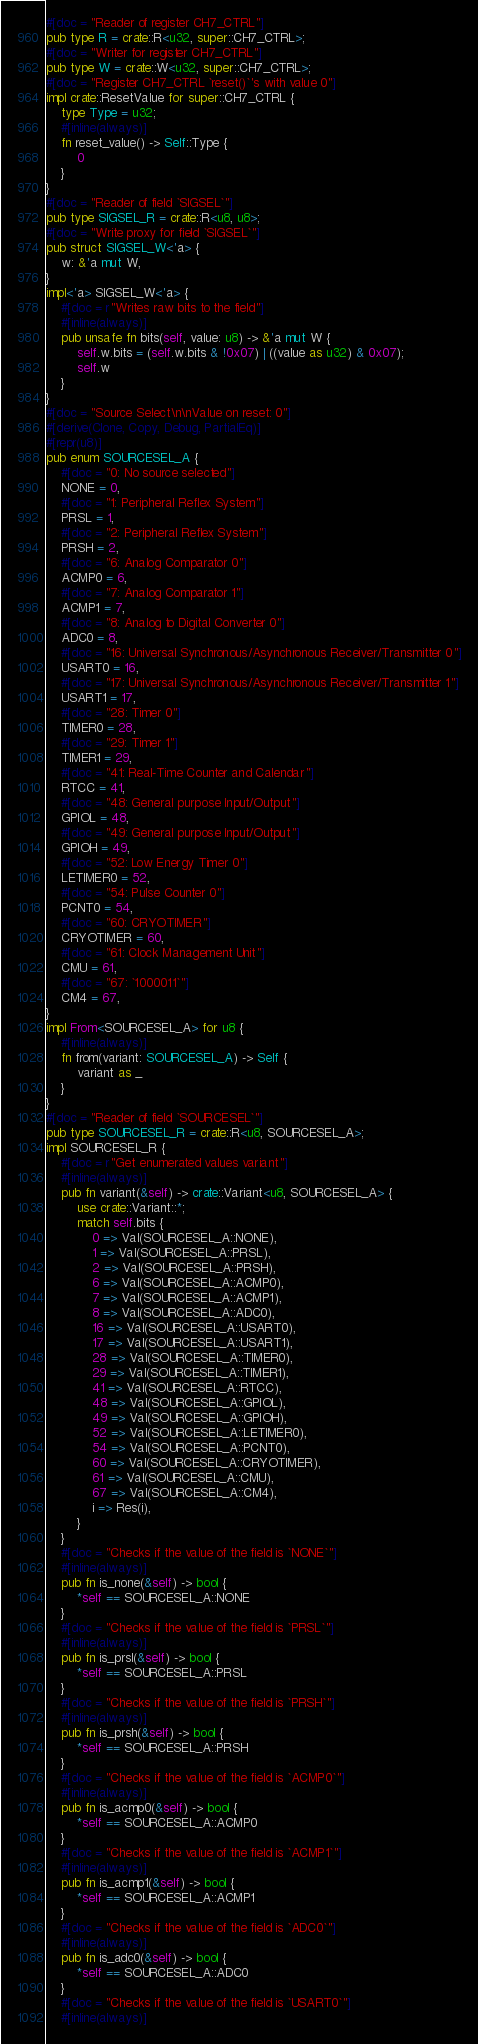Convert code to text. <code><loc_0><loc_0><loc_500><loc_500><_Rust_>#[doc = "Reader of register CH7_CTRL"]
pub type R = crate::R<u32, super::CH7_CTRL>;
#[doc = "Writer for register CH7_CTRL"]
pub type W = crate::W<u32, super::CH7_CTRL>;
#[doc = "Register CH7_CTRL `reset()`'s with value 0"]
impl crate::ResetValue for super::CH7_CTRL {
    type Type = u32;
    #[inline(always)]
    fn reset_value() -> Self::Type {
        0
    }
}
#[doc = "Reader of field `SIGSEL`"]
pub type SIGSEL_R = crate::R<u8, u8>;
#[doc = "Write proxy for field `SIGSEL`"]
pub struct SIGSEL_W<'a> {
    w: &'a mut W,
}
impl<'a> SIGSEL_W<'a> {
    #[doc = r"Writes raw bits to the field"]
    #[inline(always)]
    pub unsafe fn bits(self, value: u8) -> &'a mut W {
        self.w.bits = (self.w.bits & !0x07) | ((value as u32) & 0x07);
        self.w
    }
}
#[doc = "Source Select\n\nValue on reset: 0"]
#[derive(Clone, Copy, Debug, PartialEq)]
#[repr(u8)]
pub enum SOURCESEL_A {
    #[doc = "0: No source selected"]
    NONE = 0,
    #[doc = "1: Peripheral Reflex System"]
    PRSL = 1,
    #[doc = "2: Peripheral Reflex System"]
    PRSH = 2,
    #[doc = "6: Analog Comparator 0"]
    ACMP0 = 6,
    #[doc = "7: Analog Comparator 1"]
    ACMP1 = 7,
    #[doc = "8: Analog to Digital Converter 0"]
    ADC0 = 8,
    #[doc = "16: Universal Synchronous/Asynchronous Receiver/Transmitter 0"]
    USART0 = 16,
    #[doc = "17: Universal Synchronous/Asynchronous Receiver/Transmitter 1"]
    USART1 = 17,
    #[doc = "28: Timer 0"]
    TIMER0 = 28,
    #[doc = "29: Timer 1"]
    TIMER1 = 29,
    #[doc = "41: Real-Time Counter and Calendar"]
    RTCC = 41,
    #[doc = "48: General purpose Input/Output"]
    GPIOL = 48,
    #[doc = "49: General purpose Input/Output"]
    GPIOH = 49,
    #[doc = "52: Low Energy Timer 0"]
    LETIMER0 = 52,
    #[doc = "54: Pulse Counter 0"]
    PCNT0 = 54,
    #[doc = "60: CRYOTIMER"]
    CRYOTIMER = 60,
    #[doc = "61: Clock Management Unit"]
    CMU = 61,
    #[doc = "67: `1000011`"]
    CM4 = 67,
}
impl From<SOURCESEL_A> for u8 {
    #[inline(always)]
    fn from(variant: SOURCESEL_A) -> Self {
        variant as _
    }
}
#[doc = "Reader of field `SOURCESEL`"]
pub type SOURCESEL_R = crate::R<u8, SOURCESEL_A>;
impl SOURCESEL_R {
    #[doc = r"Get enumerated values variant"]
    #[inline(always)]
    pub fn variant(&self) -> crate::Variant<u8, SOURCESEL_A> {
        use crate::Variant::*;
        match self.bits {
            0 => Val(SOURCESEL_A::NONE),
            1 => Val(SOURCESEL_A::PRSL),
            2 => Val(SOURCESEL_A::PRSH),
            6 => Val(SOURCESEL_A::ACMP0),
            7 => Val(SOURCESEL_A::ACMP1),
            8 => Val(SOURCESEL_A::ADC0),
            16 => Val(SOURCESEL_A::USART0),
            17 => Val(SOURCESEL_A::USART1),
            28 => Val(SOURCESEL_A::TIMER0),
            29 => Val(SOURCESEL_A::TIMER1),
            41 => Val(SOURCESEL_A::RTCC),
            48 => Val(SOURCESEL_A::GPIOL),
            49 => Val(SOURCESEL_A::GPIOH),
            52 => Val(SOURCESEL_A::LETIMER0),
            54 => Val(SOURCESEL_A::PCNT0),
            60 => Val(SOURCESEL_A::CRYOTIMER),
            61 => Val(SOURCESEL_A::CMU),
            67 => Val(SOURCESEL_A::CM4),
            i => Res(i),
        }
    }
    #[doc = "Checks if the value of the field is `NONE`"]
    #[inline(always)]
    pub fn is_none(&self) -> bool {
        *self == SOURCESEL_A::NONE
    }
    #[doc = "Checks if the value of the field is `PRSL`"]
    #[inline(always)]
    pub fn is_prsl(&self) -> bool {
        *self == SOURCESEL_A::PRSL
    }
    #[doc = "Checks if the value of the field is `PRSH`"]
    #[inline(always)]
    pub fn is_prsh(&self) -> bool {
        *self == SOURCESEL_A::PRSH
    }
    #[doc = "Checks if the value of the field is `ACMP0`"]
    #[inline(always)]
    pub fn is_acmp0(&self) -> bool {
        *self == SOURCESEL_A::ACMP0
    }
    #[doc = "Checks if the value of the field is `ACMP1`"]
    #[inline(always)]
    pub fn is_acmp1(&self) -> bool {
        *self == SOURCESEL_A::ACMP1
    }
    #[doc = "Checks if the value of the field is `ADC0`"]
    #[inline(always)]
    pub fn is_adc0(&self) -> bool {
        *self == SOURCESEL_A::ADC0
    }
    #[doc = "Checks if the value of the field is `USART0`"]
    #[inline(always)]</code> 